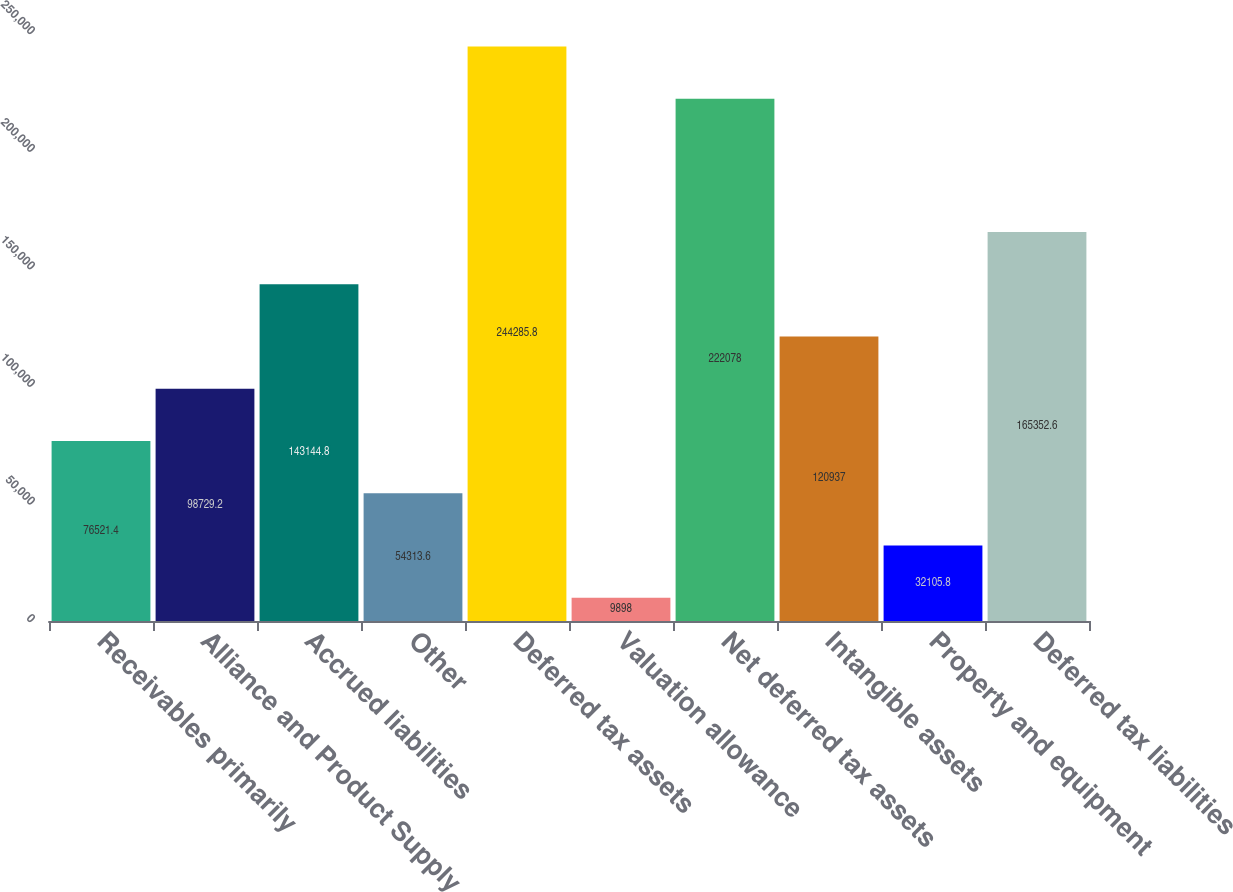Convert chart. <chart><loc_0><loc_0><loc_500><loc_500><bar_chart><fcel>Receivables primarily<fcel>Alliance and Product Supply<fcel>Accrued liabilities<fcel>Other<fcel>Deferred tax assets<fcel>Valuation allowance<fcel>Net deferred tax assets<fcel>Intangible assets<fcel>Property and equipment<fcel>Deferred tax liabilities<nl><fcel>76521.4<fcel>98729.2<fcel>143145<fcel>54313.6<fcel>244286<fcel>9898<fcel>222078<fcel>120937<fcel>32105.8<fcel>165353<nl></chart> 